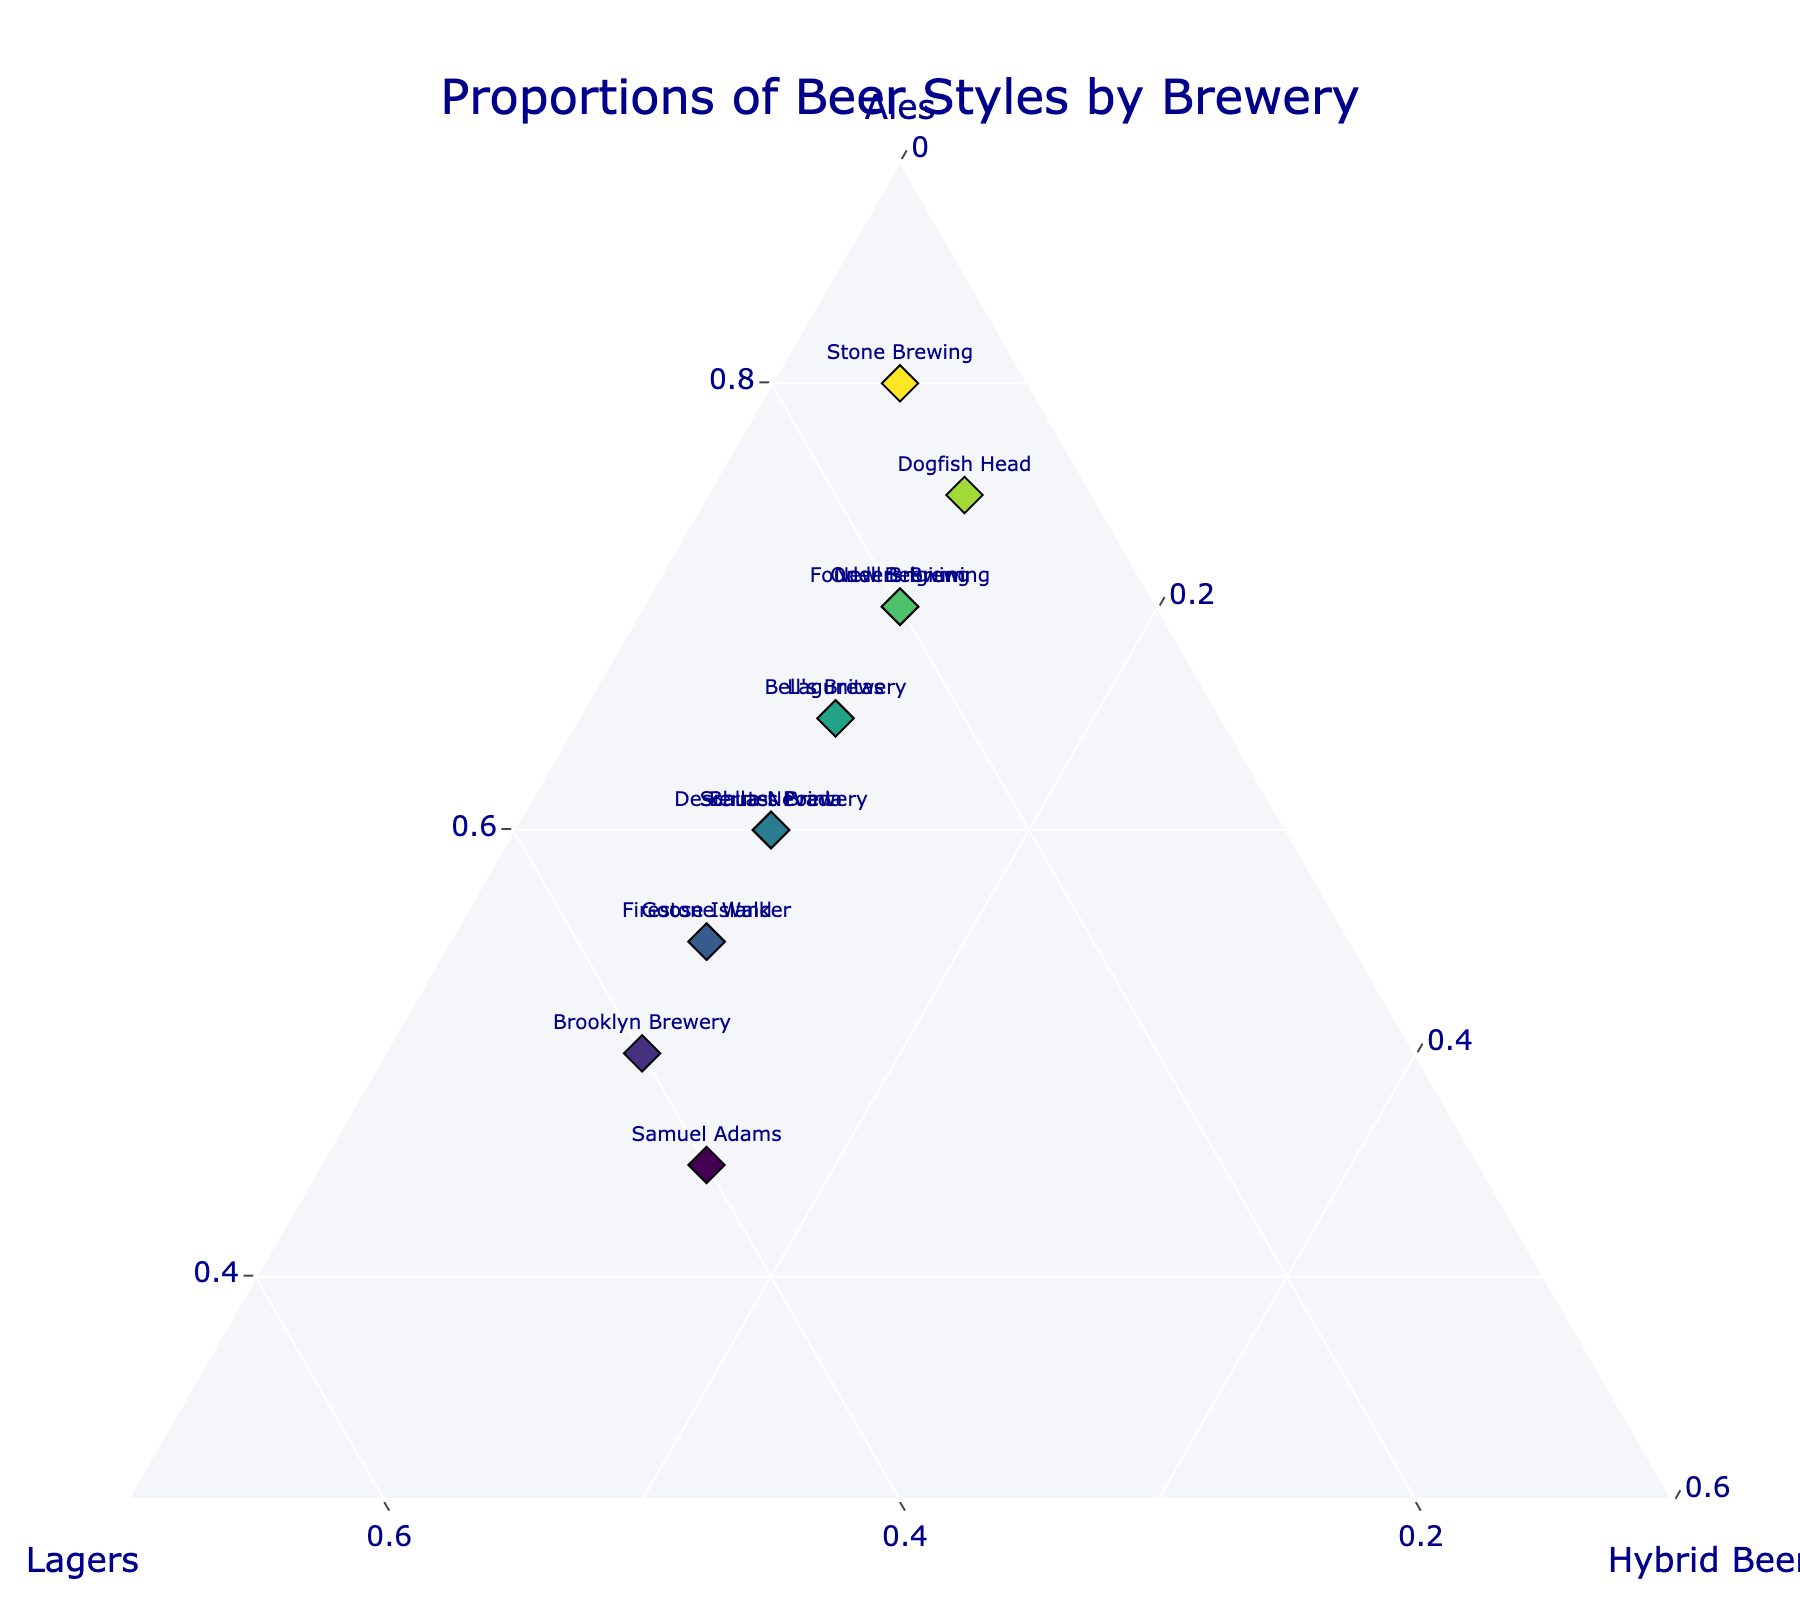Which brewery produces the highest proportion of ales? To find the brewery with the highest proportion of ales, look for the data point closest to the "Ales" axis and with the highest value for "Ales". From the plot, Stone Brewing has the highest proportion of ales at 0.80.
Answer: Stone Brewing Which brewery has an equal proportion of lagers and ales? To determine which brewery has equal proportions of lagers and ales, identify the data point where the values for "Lagers" and "Ales" are closest or equal. From the data, no brewery has exactly equal values for lagers and ales.
Answer: None What is the average proportion of hybrid beers across all breweries? Calculate the average by summing the proportions of hybrid beers and dividing by the number of breweries. The sum of hybrid beers is 0.15 + 0.10*11 + 0.05 = 1.25, and there are 14 breweries. Average = 1.25 / 14 ≈ 0.089.
Answer: 0.089 Which brewery has the lowest proportion of hybrid beers? To find the brewery with the lowest proportion of hybrid beers, identify the data point with the smallest value for "Hybrid Beers". From the plot, Stone Brewing has the smallest proportion at 0.05.
Answer: Stone Brewing Is there any brewery that produces more than 50% lagers? To determine if any brewery produces more than 50% lagers, look for data points with the proportion of "Lagers" greater than 0.50. From the plot, no brewery produces more than 50% lagers.
Answer: No How does the proportion of ales produced by Dogfish Head compare to Goose Island? Compare the value of "Ales" for Dogfish Head and Goose Island. Dogfish Head has 0.75, while Goose Island has 0.55. Dogfish Head produces more ales than Goose Island.
Answer: Dogfish Head produces more What's the combined proportion of ales and lagers for Bell's Brewery? Add the proportions of "Ales" and "Lagers" for Bell's Brewery. The proportion of ales is 0.65, and lagers is 0.25. Combined proportion = 0.65 + 0.25 = 0.90.
Answer: 0.90 Which brewery has the closest proportions of ales, lagers, and hybrid beers? To find the brewery with the closest proportions, look for a data point where the values of "Ales," "Lagers," and "Hybrid Beers" are the most similar. Samuel Adams has proportions (0.45, 0.40, 0.15), which are relatively close.
Answer: Samuel Adams If we were to combine the proportions of ales and lagers for all breweries, would it be greater or less than the combined proportion of hybrid beers? Calculate the total proportions of ales and lagers and compare them with hybrid beers. Sum of ales = 0.45 + 0.60 + 0.70 + ... + 0.70 = 8.30. Sum of lagers = 0.40 + 0.30 + 0.20 + 0.15 + ... + 0.20 = 3.90. Sum of hybrid beers = 0.15 + 0.10 + 0.10 + ... + 0.10 = 1.25. Combined ales and lagers = 8.30 + 3.90 = 12.20, which is greater than 1.25 for hybrid beers.
Answer: Greater Which brewery has the highest diversity in its beer styles' proportions? Find the brewery with the most varied proportions by examining the differences between "Ales," "Lagers," and "Hybrid Beers" values. Brooklyn Brewery has 0.50 (Ales), 0.40 (Lagers), and 0.10 (Hybrid Beers), showing a balanced mix.
Answer: Brooklyn Brewery 